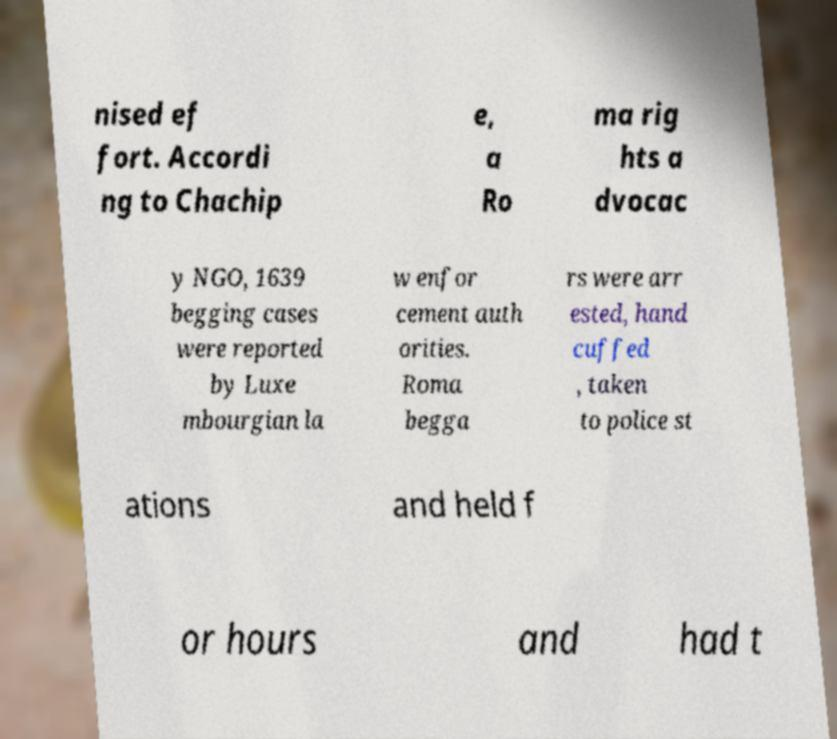Please read and relay the text visible in this image. What does it say? nised ef fort. Accordi ng to Chachip e, a Ro ma rig hts a dvocac y NGO, 1639 begging cases were reported by Luxe mbourgian la w enfor cement auth orities. Roma begga rs were arr ested, hand cuffed , taken to police st ations and held f or hours and had t 